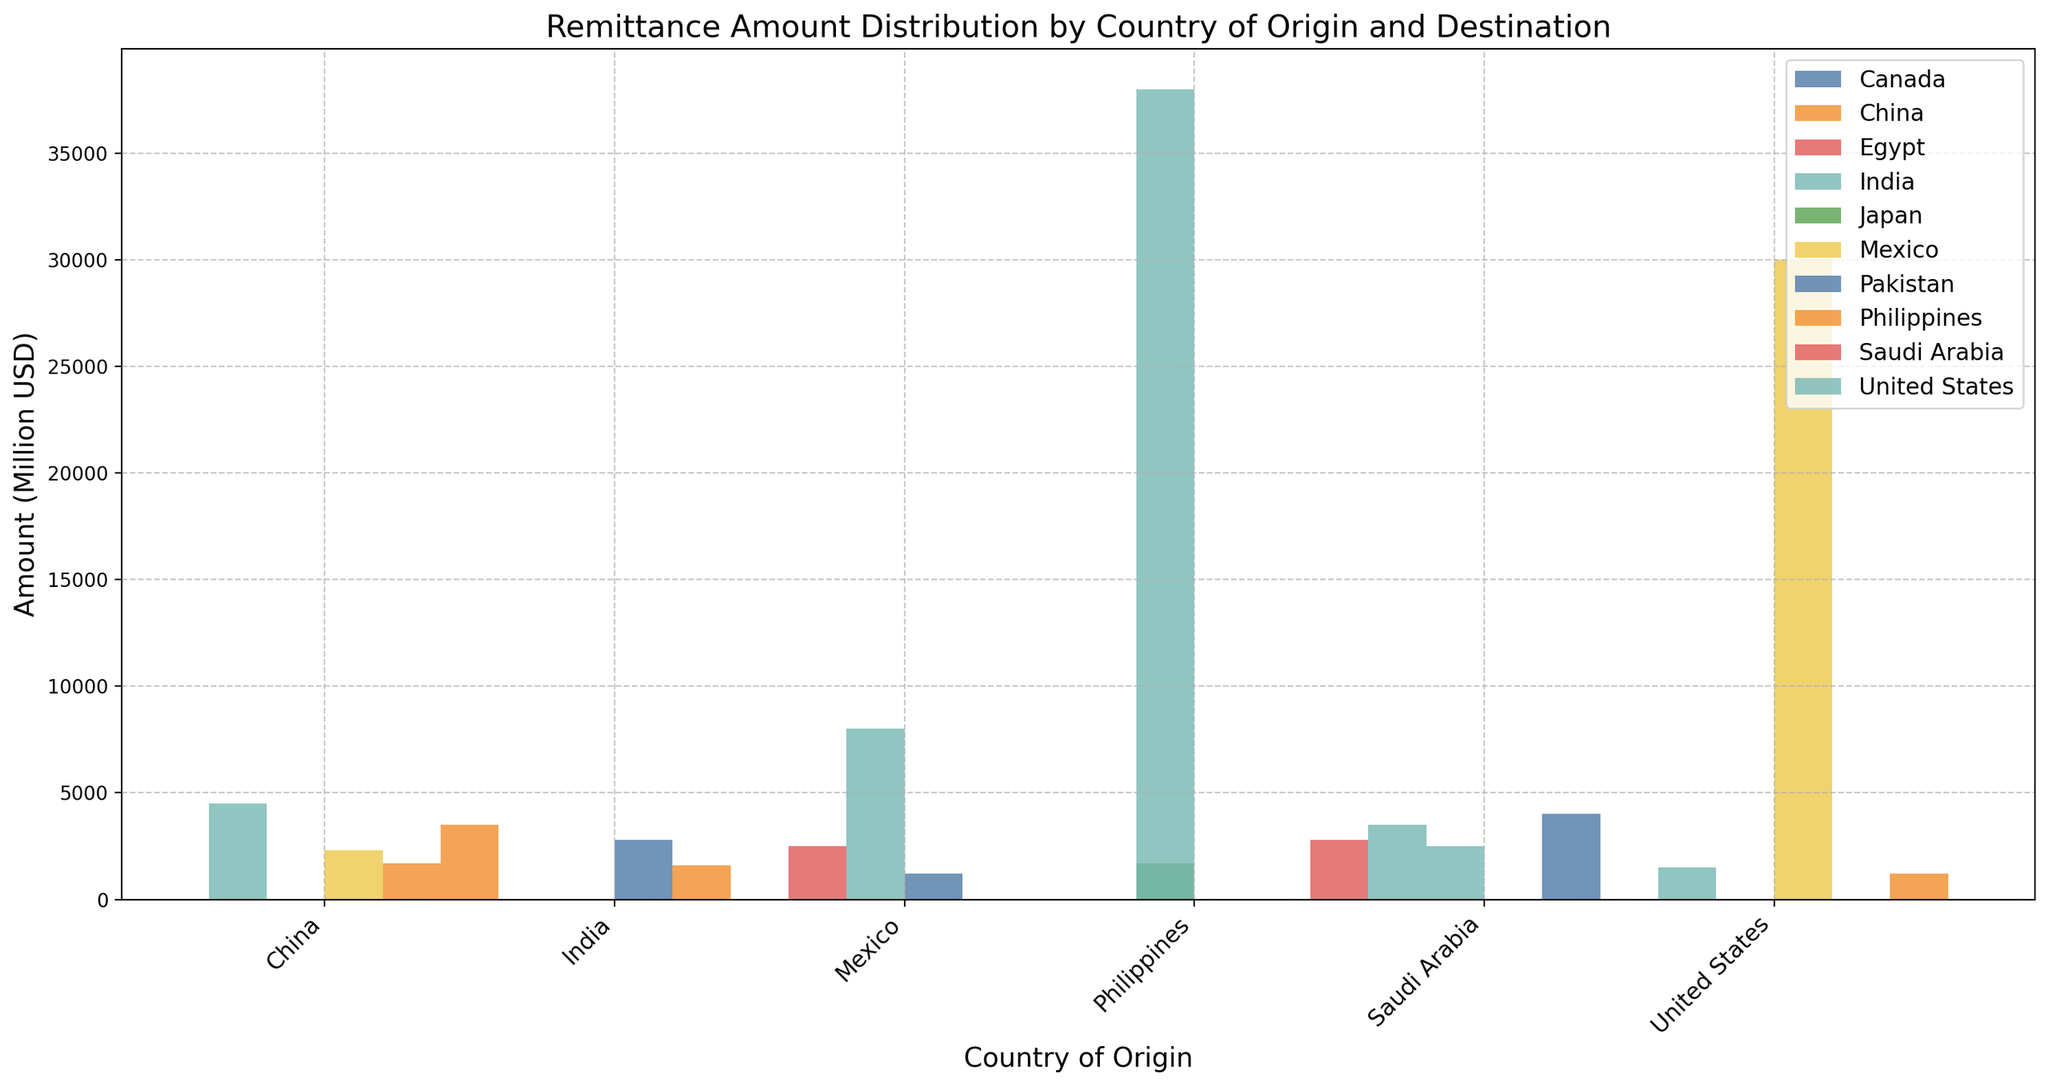What's the total remittance amount from the United States? To find the total remittance amount from the United States, add the values of all destinations from the United States. The amounts are 30000 (Mexico), 1500 (India), and 1200 (Philippines). So, the total is 30000 + 1500 + 1200 = 32700.
Answer: 32700 Which country receives the highest remittance from Mexico? Compare the remittance amounts Mexico sends to different countries. The amounts are 1600 (China), 38000 (United States), and 2800 (Canada). The highest among these is 38000 to the United States.
Answer: United States Is the remittance amount from China to India greater than from India to China? Compare the two amounts: China to India is 4500 and India to China is 1700. Since 4500 is greater than 1700, the answer is yes.
Answer: Yes What is the average remittance amount received by the Philippines from all other countries? The Philippines receives remittances from China (3500), United States (1200), Canada (1200), and Japan (1700). First, sum these amounts: 3500 + 1200 + 1200 + 1700 = 7600. Then, divide by the number of countries (4): 7600 / 4 = 1900.
Answer: 1900 Which country sends more remittance to India, Saudi Arabia, or the United States? Compare the remittance amounts sent to India by Saudi Arabia (3500) and the United States (1500). Since 3500 is greater than 1500, Saudi Arabia sends more.
Answer: Saudi Arabia How does the remittance amount from the Philippines to the United States compare to the amount from Mexico to the United States? Compare the two amounts: Philippines to United States is 2500 and Mexico to United States is 38000. Since 2500 is much less than 38000, Mexico sends much more.
Answer: Mexico sends much more What's the difference in the remittance amount from Saudi Arabia to India and Pakistan? The remittance amounts are 3500 (India) and 4000 (Pakistan). The difference is 4000 - 3500 = 500.
Answer: 500 What is the total remittance amount received by China from all other countries? China receives remittances from India (1700) and Mexico (1600). Sum these amounts: 1700 + 1600 = 3300.
Answer: 3300 Which country of origin has the smallest total remittance amount? Sum the remittance amounts for each country of origin: China (3500 + 4500 + 2300 = 10300), India (1700 + 8000 + 2500 = 12200), Philippines (2500 + 1200 + 1700 = 5400), Mexico (1600 + 38000 + 2800 = 42400), United States (30000 + 1500 + 1200 = 32700), Saudi Arabia (4000 + 3500 + 2800 = 10300). The smallest total is for the Philippines with 5400.
Answer: Philippines 